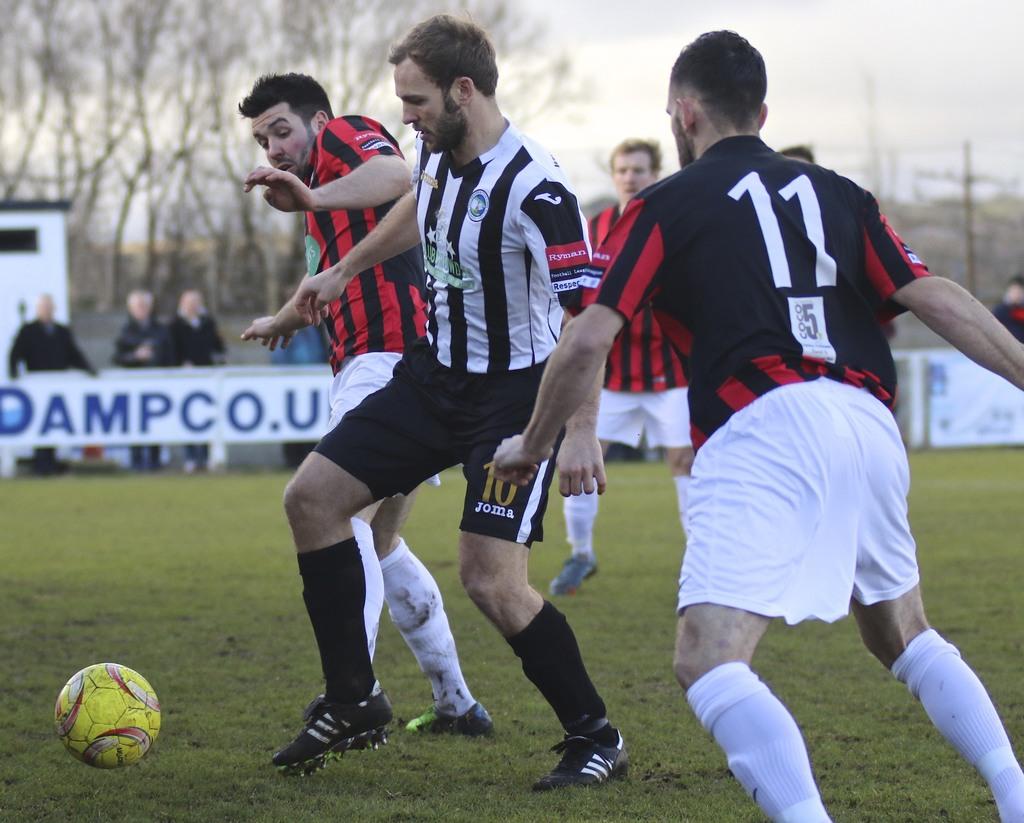What is the number on the red and black jersey?
Offer a very short reply. 11. What word is printed on the black shorts?
Ensure brevity in your answer.  Joma. 